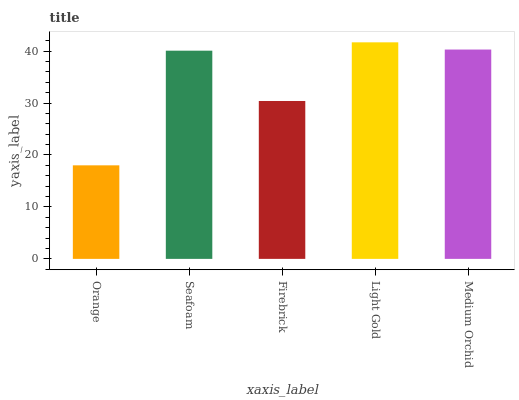Is Orange the minimum?
Answer yes or no. Yes. Is Light Gold the maximum?
Answer yes or no. Yes. Is Seafoam the minimum?
Answer yes or no. No. Is Seafoam the maximum?
Answer yes or no. No. Is Seafoam greater than Orange?
Answer yes or no. Yes. Is Orange less than Seafoam?
Answer yes or no. Yes. Is Orange greater than Seafoam?
Answer yes or no. No. Is Seafoam less than Orange?
Answer yes or no. No. Is Seafoam the high median?
Answer yes or no. Yes. Is Seafoam the low median?
Answer yes or no. Yes. Is Firebrick the high median?
Answer yes or no. No. Is Light Gold the low median?
Answer yes or no. No. 